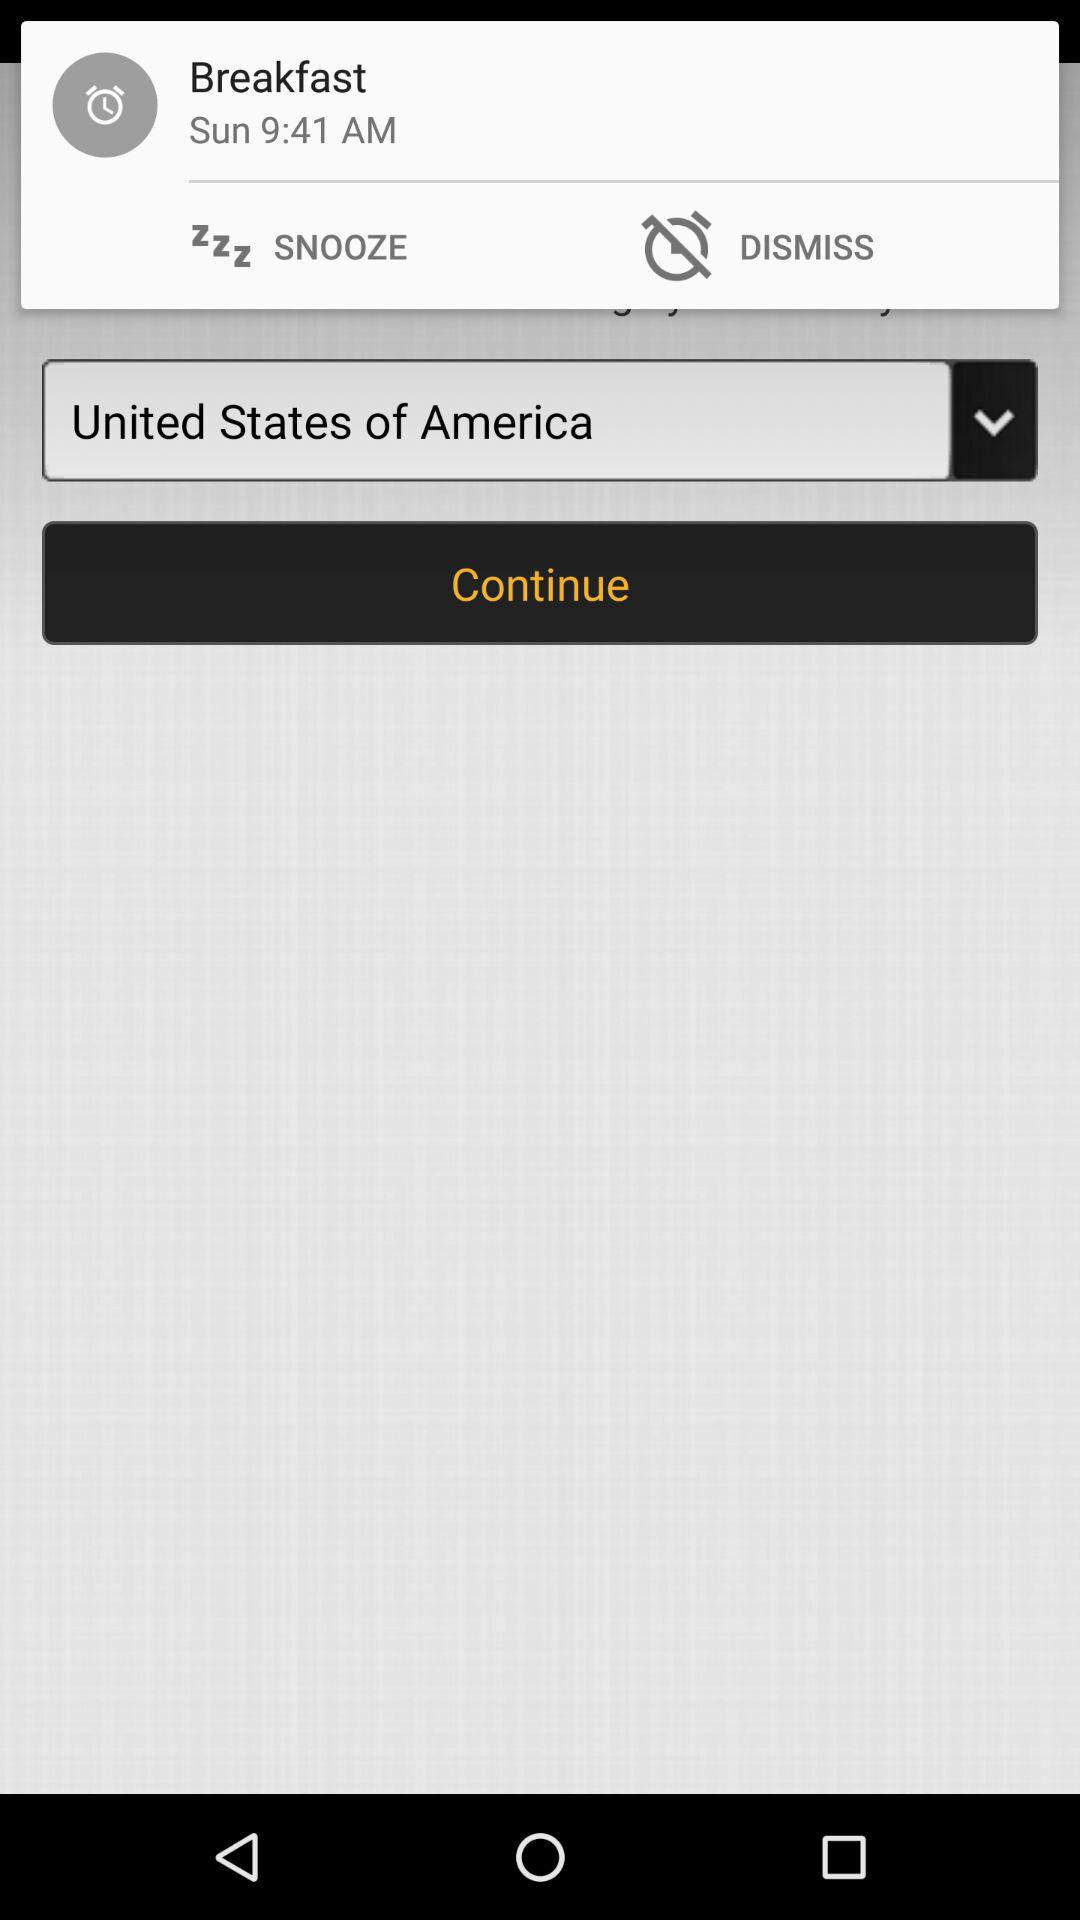What is the selected country? The selected country is the United States of America. 